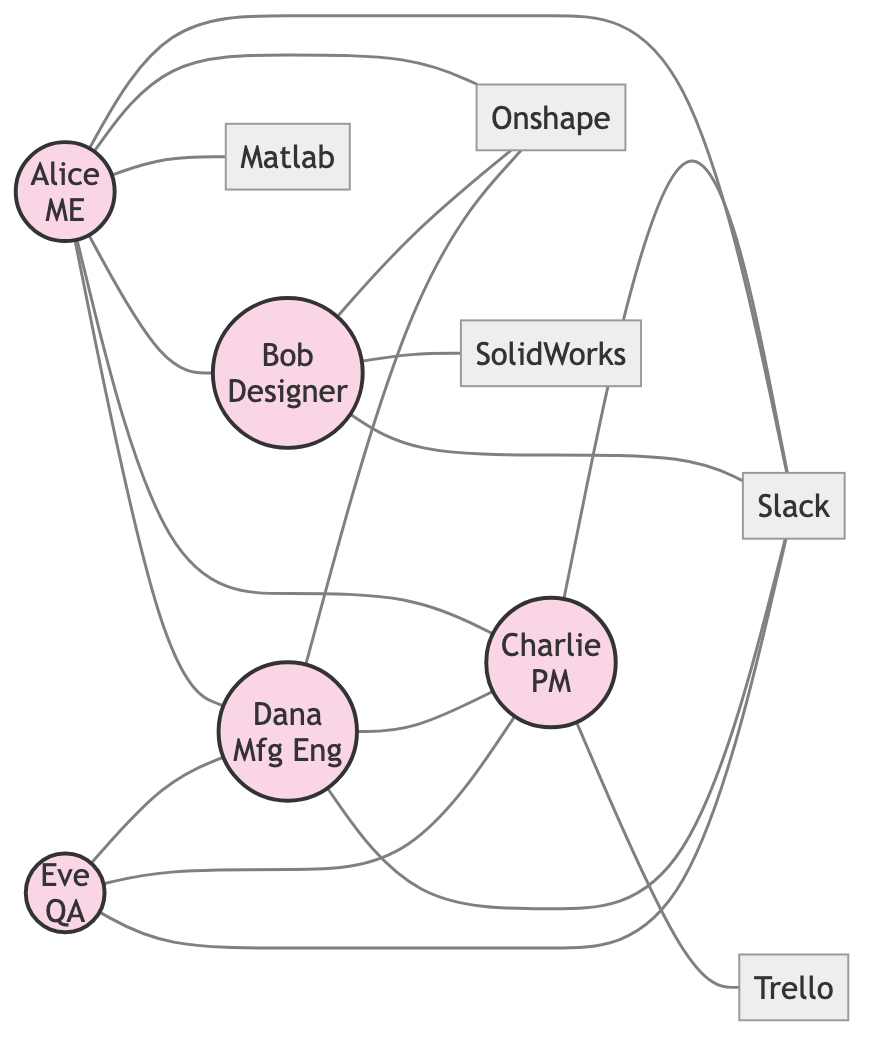What's the total number of nodes in the diagram? The diagram includes individuals and tools involved in collaboration. Counting the "nodes" in the data provided, we have 5 people and 5 tools, resulting in a total of 10 nodes.
Answer: 10 Which tool does Alice use for CAD? According to the edges, Alice has an edge that connects her to Onshape indicating that she uses this tool for CAD.
Answer: Onshape Who does Dana report to? From the diagram, Dana has a direct edge connecting her to Charlie, indicating that she reports to him.
Answer: Charlie How many tools are used by Bob? Bob is connected to two tools: Onshape and SolidWorks, as indicated by the edges. Therefore, he uses 2 tools.
Answer: 2 Which role has the most connections in the collaboration network? By examining the number of edges associated with each role, Alice has five connections with other nodes, more than any other role in the diagram.
Answer: Alice How many times does Eve communicate with the team? Eve is shown to communicate with the team through a direct connection to the Slack node. According to the edges, she communicates only one time, indicated by her one edge that connects to Slack.
Answer: 1 What is Charlie's primary responsibility according to the edges? Charlie manages projects as shown by the direct connection to Trello, which is designated as a project management tool.
Answer: Manages projects Is there any collaboration between Alice and Dana? Yes, there is an edge between Alice and Dana, indicating that they work together on prototypes. This collaboration is explicitly stated in the relationships of the edges.
Answer: Yes How many people are connected to Slack? Upon reviewing the nodes connected to Slack, we find that four individuals (Alice, Bob, Dana, and Eve) have direct connections to it. Thus, there are 4 connections.
Answer: 4 